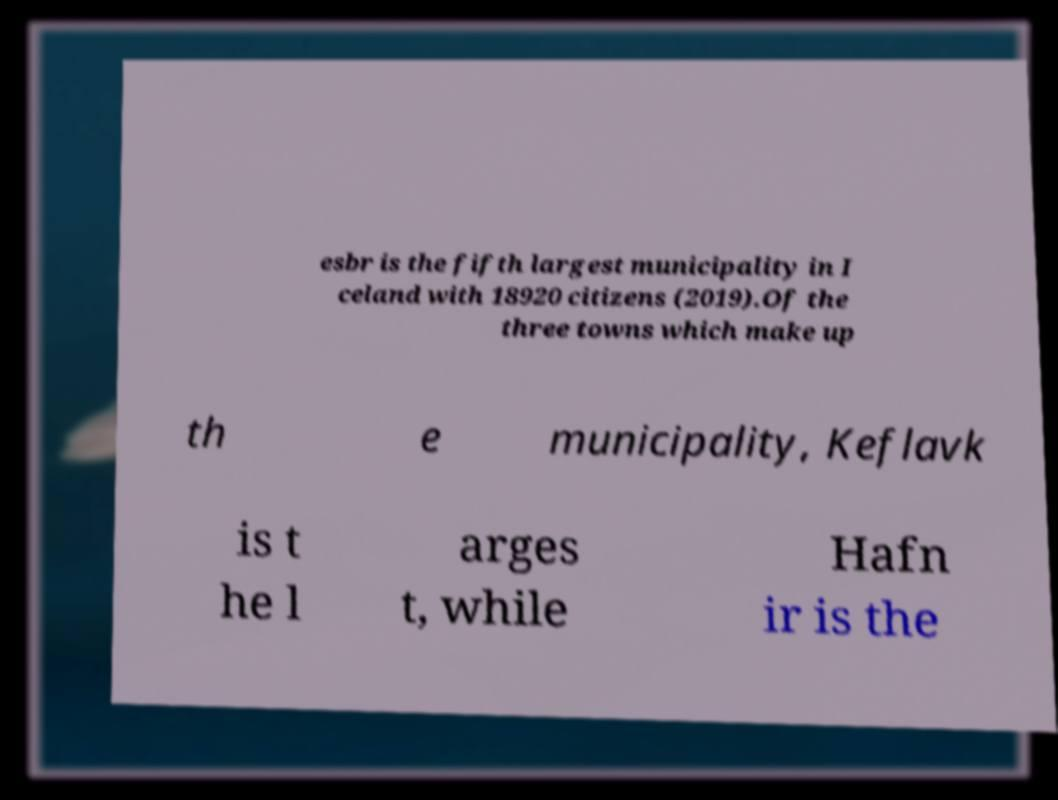Could you assist in decoding the text presented in this image and type it out clearly? esbr is the fifth largest municipality in I celand with 18920 citizens (2019).Of the three towns which make up th e municipality, Keflavk is t he l arges t, while Hafn ir is the 